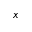<formula> <loc_0><loc_0><loc_500><loc_500>x</formula> 